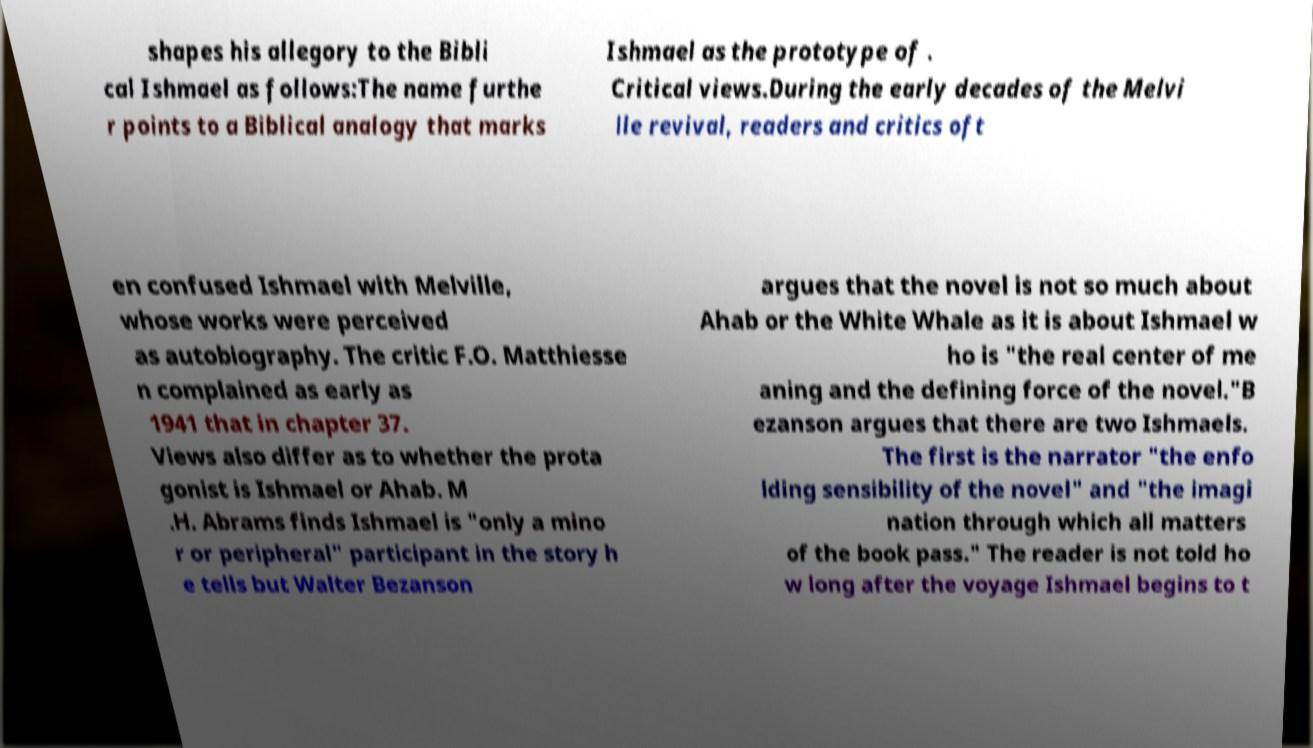Could you extract and type out the text from this image? shapes his allegory to the Bibli cal Ishmael as follows:The name furthe r points to a Biblical analogy that marks Ishmael as the prototype of . Critical views.During the early decades of the Melvi lle revival, readers and critics oft en confused Ishmael with Melville, whose works were perceived as autobiography. The critic F.O. Matthiesse n complained as early as 1941 that in chapter 37. Views also differ as to whether the prota gonist is Ishmael or Ahab. M .H. Abrams finds Ishmael is "only a mino r or peripheral" participant in the story h e tells but Walter Bezanson argues that the novel is not so much about Ahab or the White Whale as it is about Ishmael w ho is "the real center of me aning and the defining force of the novel."B ezanson argues that there are two Ishmaels. The first is the narrator "the enfo lding sensibility of the novel" and "the imagi nation through which all matters of the book pass." The reader is not told ho w long after the voyage Ishmael begins to t 